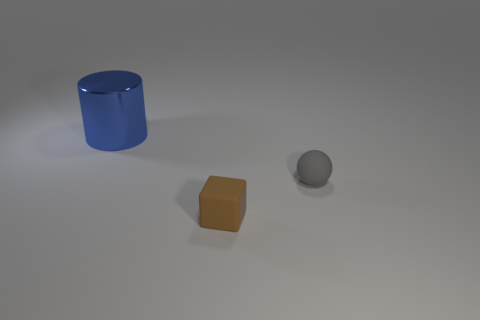What shape is the tiny object that is the same material as the small brown cube? The tiny object that appears to share the matte finish and color characteristics with the small brown cube is a sphere. 